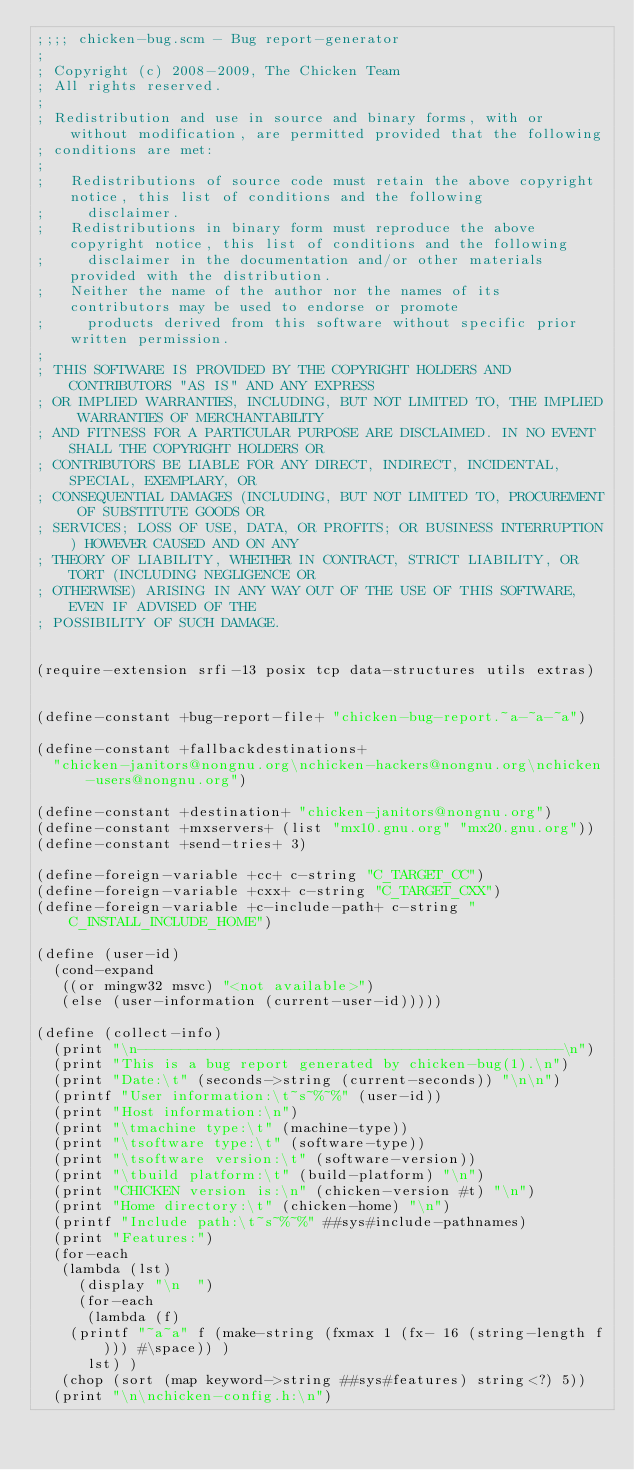<code> <loc_0><loc_0><loc_500><loc_500><_Scheme_>;;;; chicken-bug.scm - Bug report-generator
;
; Copyright (c) 2008-2009, The Chicken Team
; All rights reserved.
;
; Redistribution and use in source and binary forms, with or without modification, are permitted provided that the following
; conditions are met:
;
;   Redistributions of source code must retain the above copyright notice, this list of conditions and the following
;     disclaimer. 
;   Redistributions in binary form must reproduce the above copyright notice, this list of conditions and the following
;     disclaimer in the documentation and/or other materials provided with the distribution. 
;   Neither the name of the author nor the names of its contributors may be used to endorse or promote
;     products derived from this software without specific prior written permission. 
;
; THIS SOFTWARE IS PROVIDED BY THE COPYRIGHT HOLDERS AND CONTRIBUTORS "AS IS" AND ANY EXPRESS
; OR IMPLIED WARRANTIES, INCLUDING, BUT NOT LIMITED TO, THE IMPLIED WARRANTIES OF MERCHANTABILITY
; AND FITNESS FOR A PARTICULAR PURPOSE ARE DISCLAIMED. IN NO EVENT SHALL THE COPYRIGHT HOLDERS OR
; CONTRIBUTORS BE LIABLE FOR ANY DIRECT, INDIRECT, INCIDENTAL, SPECIAL, EXEMPLARY, OR
; CONSEQUENTIAL DAMAGES (INCLUDING, BUT NOT LIMITED TO, PROCUREMENT OF SUBSTITUTE GOODS OR
; SERVICES; LOSS OF USE, DATA, OR PROFITS; OR BUSINESS INTERRUPTION) HOWEVER CAUSED AND ON ANY
; THEORY OF LIABILITY, WHETHER IN CONTRACT, STRICT LIABILITY, OR TORT (INCLUDING NEGLIGENCE OR
; OTHERWISE) ARISING IN ANY WAY OUT OF THE USE OF THIS SOFTWARE, EVEN IF ADVISED OF THE
; POSSIBILITY OF SUCH DAMAGE.


(require-extension srfi-13 posix tcp data-structures utils extras)


(define-constant +bug-report-file+ "chicken-bug-report.~a-~a-~a")

(define-constant +fallbackdestinations+ 
  "chicken-janitors@nongnu.org\nchicken-hackers@nongnu.org\nchicken-users@nongnu.org")

(define-constant +destination+ "chicken-janitors@nongnu.org")
(define-constant +mxservers+ (list "mx10.gnu.org" "mx20.gnu.org"))
(define-constant +send-tries+ 3)

(define-foreign-variable +cc+ c-string "C_TARGET_CC")
(define-foreign-variable +cxx+ c-string "C_TARGET_CXX")
(define-foreign-variable +c-include-path+ c-string "C_INSTALL_INCLUDE_HOME")

(define (user-id)
  (cond-expand
   ((or mingw32 msvc) "<not available>")
   (else (user-information (current-user-id)))))

(define (collect-info)
  (print "\n--------------------------------------------------\n")
  (print "This is a bug report generated by chicken-bug(1).\n")
  (print "Date:\t" (seconds->string (current-seconds)) "\n\n")
  (printf "User information:\t~s~%~%" (user-id))
  (print "Host information:\n")
  (print "\tmachine type:\t" (machine-type))
  (print "\tsoftware type:\t" (software-type))
  (print "\tsoftware version:\t" (software-version))
  (print "\tbuild platform:\t" (build-platform) "\n")
  (print "CHICKEN version is:\n" (chicken-version #t) "\n")
  (print "Home directory:\t" (chicken-home) "\n")
  (printf "Include path:\t~s~%~%" ##sys#include-pathnames)
  (print "Features:")
  (for-each
   (lambda (lst) 
     (display "\n  ")
     (for-each 
      (lambda (f)
	(printf "~a~a" f (make-string (fxmax 1 (fx- 16 (string-length f))) #\space)) )
      lst) )
   (chop (sort (map keyword->string ##sys#features) string<?) 5))
  (print "\n\nchicken-config.h:\n")</code> 